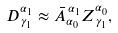<formula> <loc_0><loc_0><loc_500><loc_500>D _ { \, \gamma _ { 1 } } ^ { \alpha _ { 1 } } \approx \bar { A } _ { \alpha _ { 0 } } ^ { \, \alpha _ { 1 } } Z _ { \, \gamma _ { 1 } } ^ { \alpha _ { 0 } } ,</formula> 